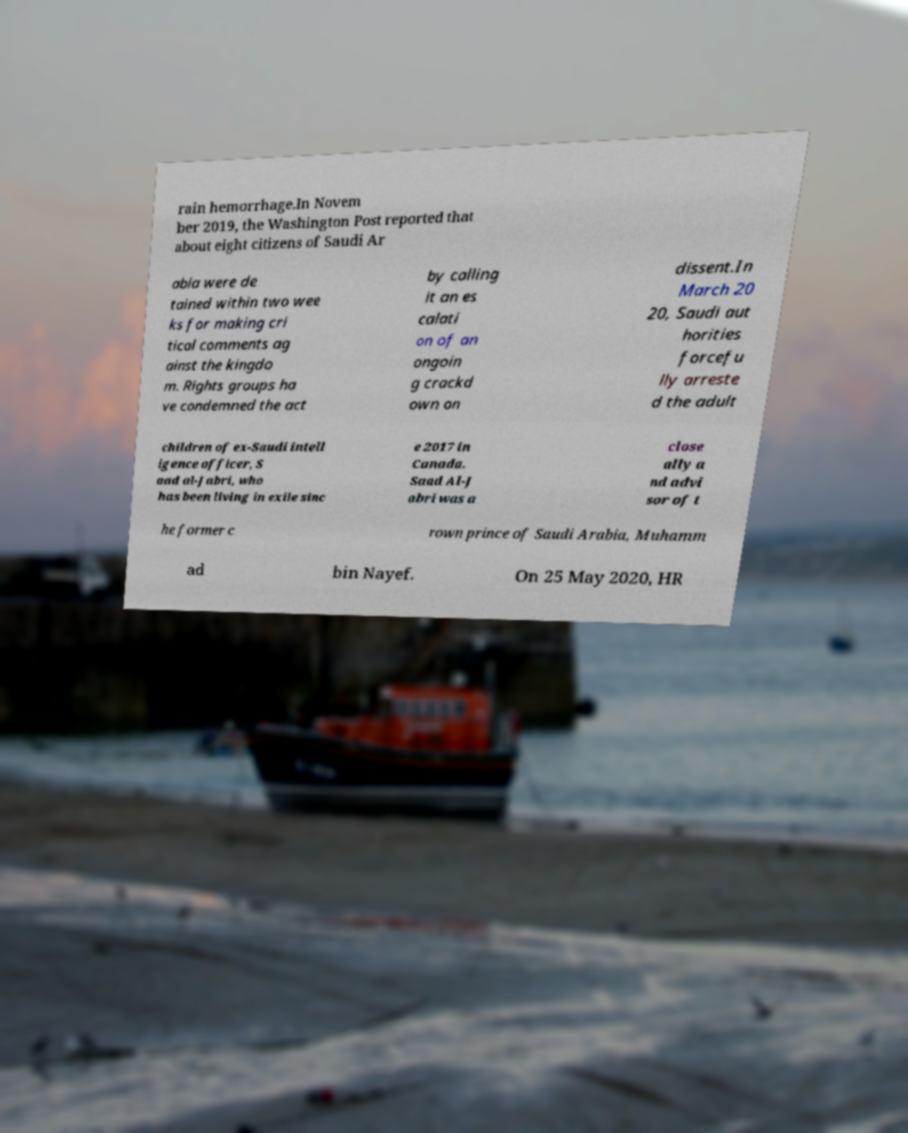There's text embedded in this image that I need extracted. Can you transcribe it verbatim? rain hemorrhage.In Novem ber 2019, the Washington Post reported that about eight citizens of Saudi Ar abia were de tained within two wee ks for making cri tical comments ag ainst the kingdo m. Rights groups ha ve condemned the act by calling it an es calati on of an ongoin g crackd own on dissent.In March 20 20, Saudi aut horities forcefu lly arreste d the adult children of ex-Saudi intell igence officer, S aad al-Jabri, who has been living in exile sinc e 2017 in Canada. Saad Al-J abri was a close ally a nd advi sor of t he former c rown prince of Saudi Arabia, Muhamm ad bin Nayef. On 25 May 2020, HR 